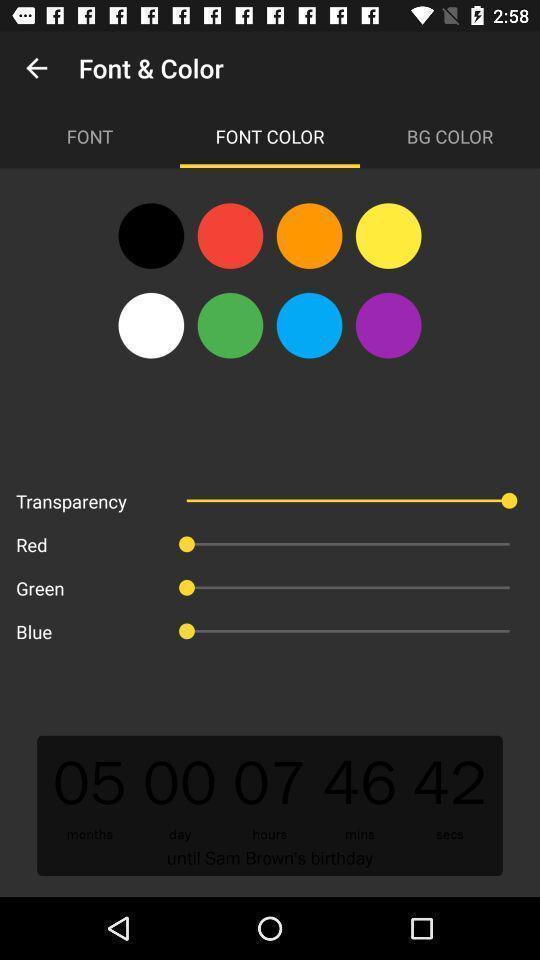Tell me what you see in this picture. Screen shows multiple color options. 